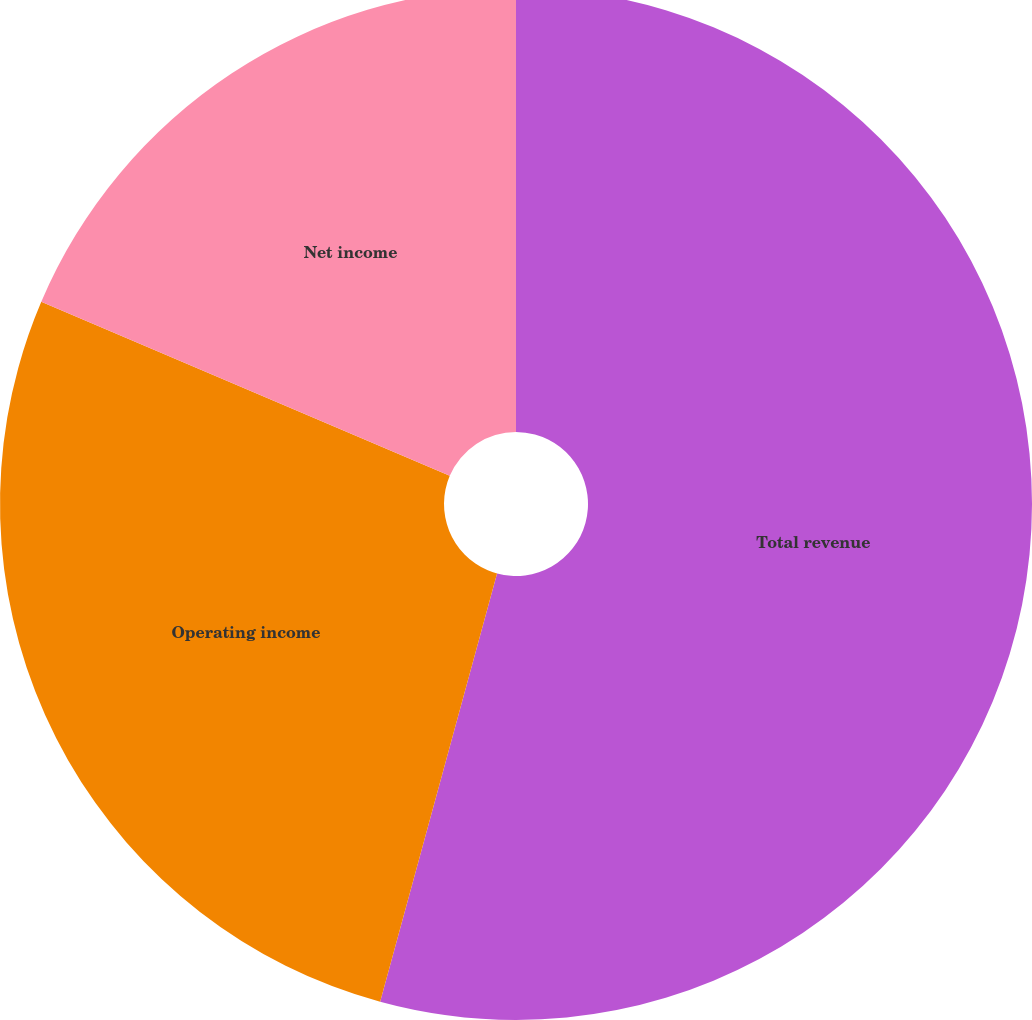Convert chart to OTSL. <chart><loc_0><loc_0><loc_500><loc_500><pie_chart><fcel>Total revenue<fcel>Operating income<fcel>Net income<nl><fcel>54.24%<fcel>27.17%<fcel>18.59%<nl></chart> 